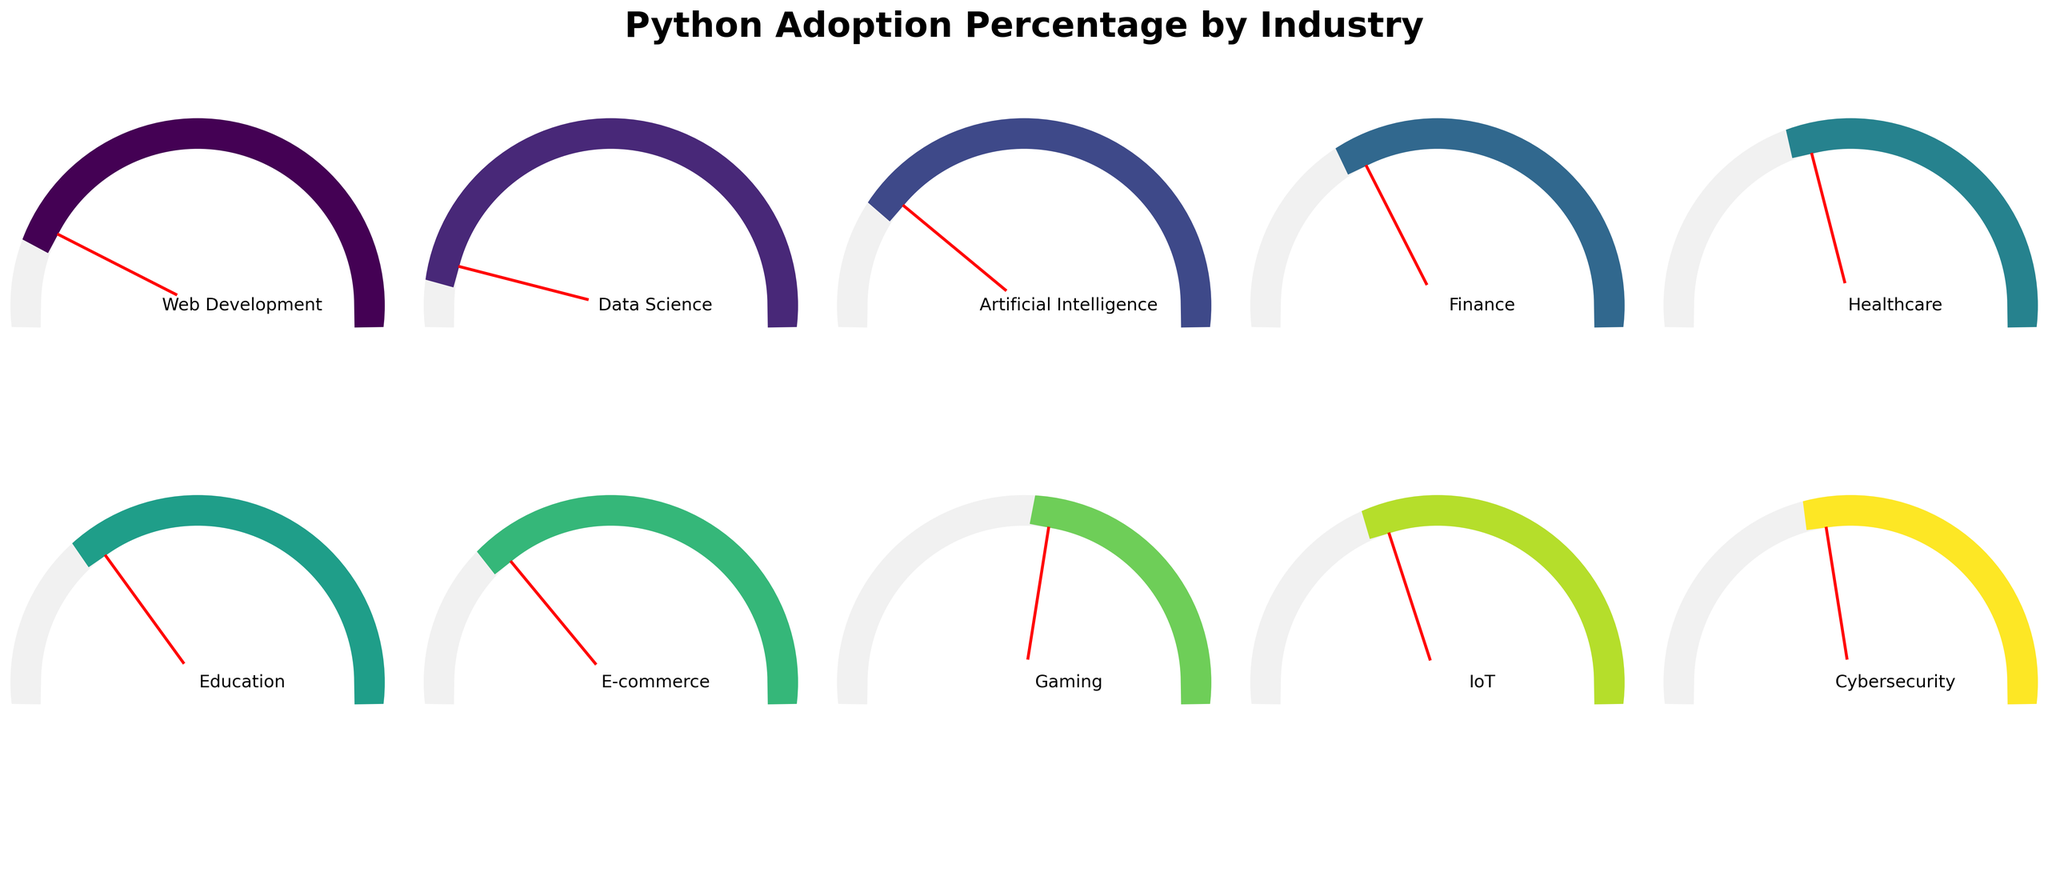Which industry sector has the highest Python adoption percentage? The gauge chart shows that the Data Science sector has an adoption percentage of 92%, which is the highest among all listed sectors.
Answer: Data Science Which industry sector has the lowest Python adoption percentage? The gauge chart shows that the Gaming sector has an adoption percentage of 45%, which is the lowest among all listed sectors.
Answer: Gaming What is the difference in Python adoption percentage between Data Science and Web Development? Data Science has an adoption percentage of 92% and Web Development has 85%. The difference is calculated as 92% - 85% = 7%.
Answer: 7% What is the average Python adoption percentage across all listed industry sectors? To find the average, sum the percentages and then divide by the number of sectors: (85 + 92 + 78 + 65 + 58 + 70 + 72 + 45 + 60 + 55) / 10 = 68%.
Answer: 68% How many industry sectors have a Python adoption percentage above 70%? By examining the percentages: Web Development (85%), Data Science (92%), Artificial Intelligence (78%), and E-commerce (72%) each have percentages above 70%. Thus, the count is 4.
Answer: 4 Which industry sectors have a Python adoption percentage between 50% and 70%? The sectors falling within that range are Finance (65%), Healthcare (58%), Education (70%), IoT (60%), and Cybersecurity (55%).
Answer: Finance, Healthcare, IoT, Cybersecurity What is the median Python adoption percentage across all listed industry sectors? Organize the percentages in ascending order: 45, 55, 58, 60, 65, 70, 72, 78, 85, 92. Since there are 10 data points, the median is the average of the 5th and 6th values: (65 + 70) / 2 = 67.5%.
Answer: 67.5% Which two industry sectors have the closest Python adoption percentages, and what is the difference? The closest percentages are between Education (70%) and E-commerce (72%), which have a difference of 2%.
Answer: Education and E-commerce, 2% 